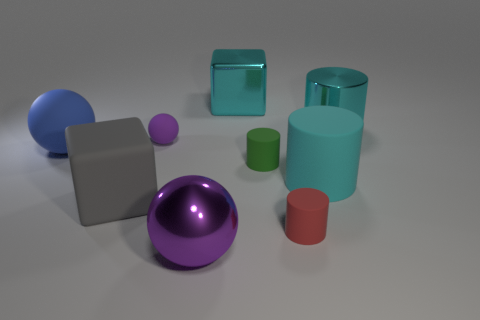Subtract all shiny cylinders. How many cylinders are left? 3 Subtract 2 cylinders. How many cylinders are left? 2 Add 1 tiny spheres. How many objects exist? 10 Subtract all blue balls. How many balls are left? 2 Subtract all cubes. How many objects are left? 7 Subtract all gray blocks. Subtract all brown spheres. How many blocks are left? 1 Subtract all blue balls. How many green blocks are left? 0 Subtract all large purple metallic things. Subtract all big metallic objects. How many objects are left? 5 Add 1 large blue balls. How many large blue balls are left? 2 Add 4 large balls. How many large balls exist? 6 